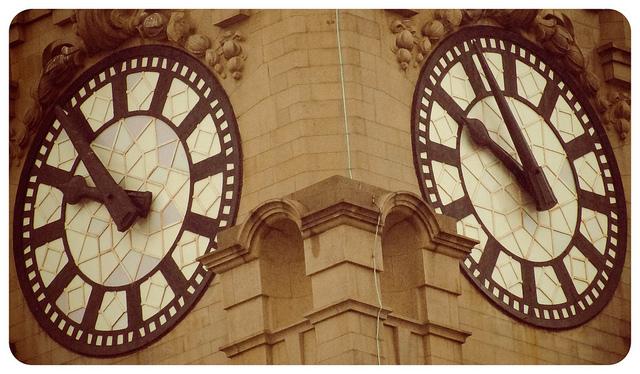Does the clock display digital?
Write a very short answer. No. Are the two clocks displaying the same time?
Write a very short answer. Yes. What time is it?
Write a very short answer. 9:55. 